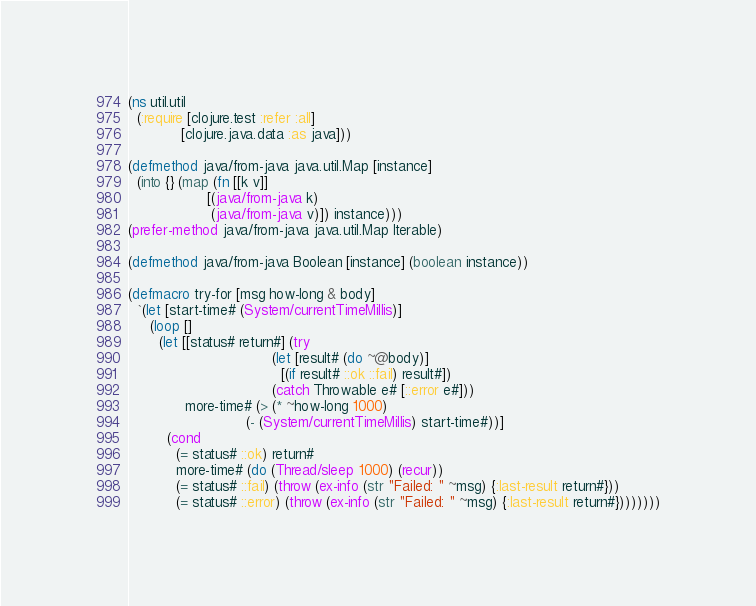<code> <loc_0><loc_0><loc_500><loc_500><_Clojure_>(ns util.util
  (:require [clojure.test :refer :all]
            [clojure.java.data :as java]))

(defmethod java/from-java java.util.Map [instance]
  (into {} (map (fn [[k v]]
                  [(java/from-java k)
                   (java/from-java v)]) instance)))
(prefer-method java/from-java java.util.Map Iterable)

(defmethod java/from-java Boolean [instance] (boolean instance))

(defmacro try-for [msg how-long & body]
  `(let [start-time# (System/currentTimeMillis)]
     (loop []
       (let [[status# return#] (try
                                 (let [result# (do ~@body)]
                                   [(if result# ::ok ::fail) result#])
                                 (catch Throwable e# [::error e#]))
             more-time# (> (* ~how-long 1000)
                           (- (System/currentTimeMillis) start-time#))]
         (cond
           (= status# ::ok) return#
           more-time# (do (Thread/sleep 1000) (recur))
           (= status# ::fail) (throw (ex-info (str "Failed: " ~msg) {:last-result return#}))
           (= status# ::error) (throw (ex-info (str "Failed: " ~msg) {:last-result return#})))))))</code> 